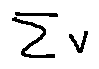Convert formula to latex. <formula><loc_0><loc_0><loc_500><loc_500>\sum v</formula> 